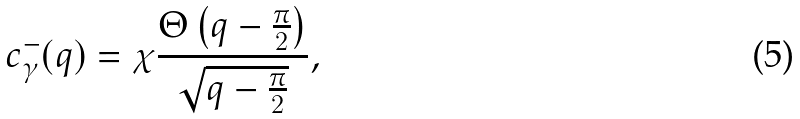Convert formula to latex. <formula><loc_0><loc_0><loc_500><loc_500>c ^ { - } _ { \gamma } ( q ) = \chi \frac { \Theta \left ( q - \frac { \pi } { 2 } \right ) } { \sqrt { q - \frac { \pi } { 2 } } } ,</formula> 